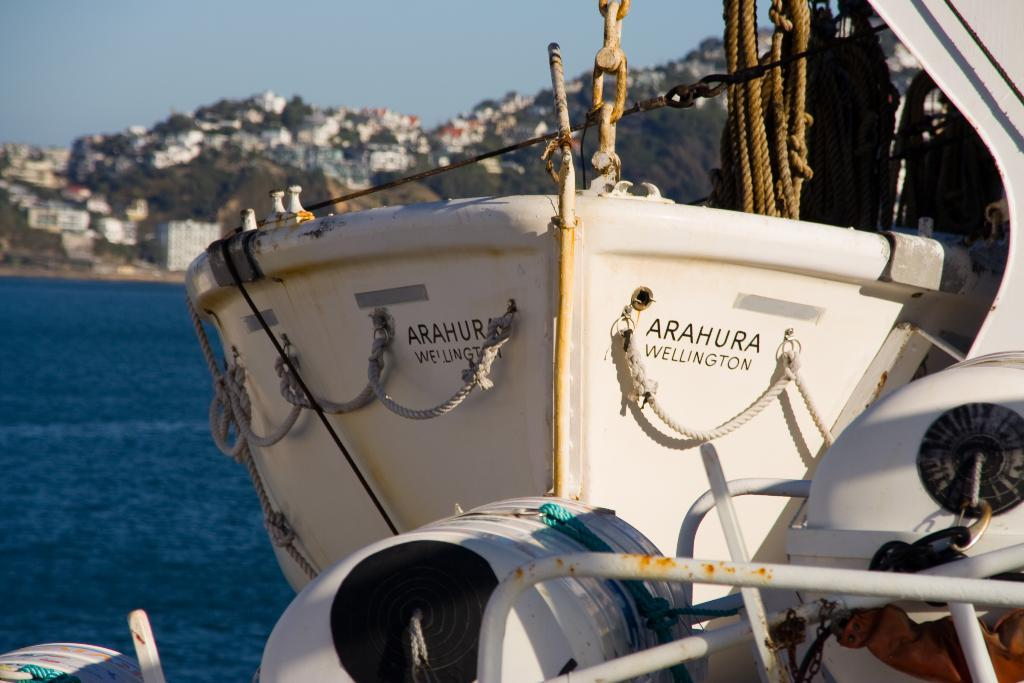What is the main subject of the image? The main subject of the image is a boat. What is attached to the boat in the image? There is a rope and a chain attached to the boat in the image. What can be seen in the background of the image? There are buildings, trees, and the sky visible in the image. What is the primary setting of the image? The primary setting of the image is water, as it is visible in the image. What type of mint is growing near the boat in the image? There is no mint growing near the boat in the image. 